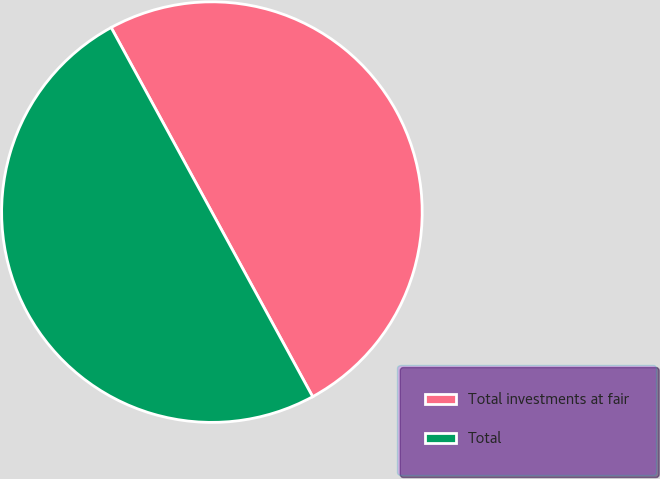<chart> <loc_0><loc_0><loc_500><loc_500><pie_chart><fcel>Total investments at fair<fcel>Total<nl><fcel>50.0%<fcel>50.0%<nl></chart> 